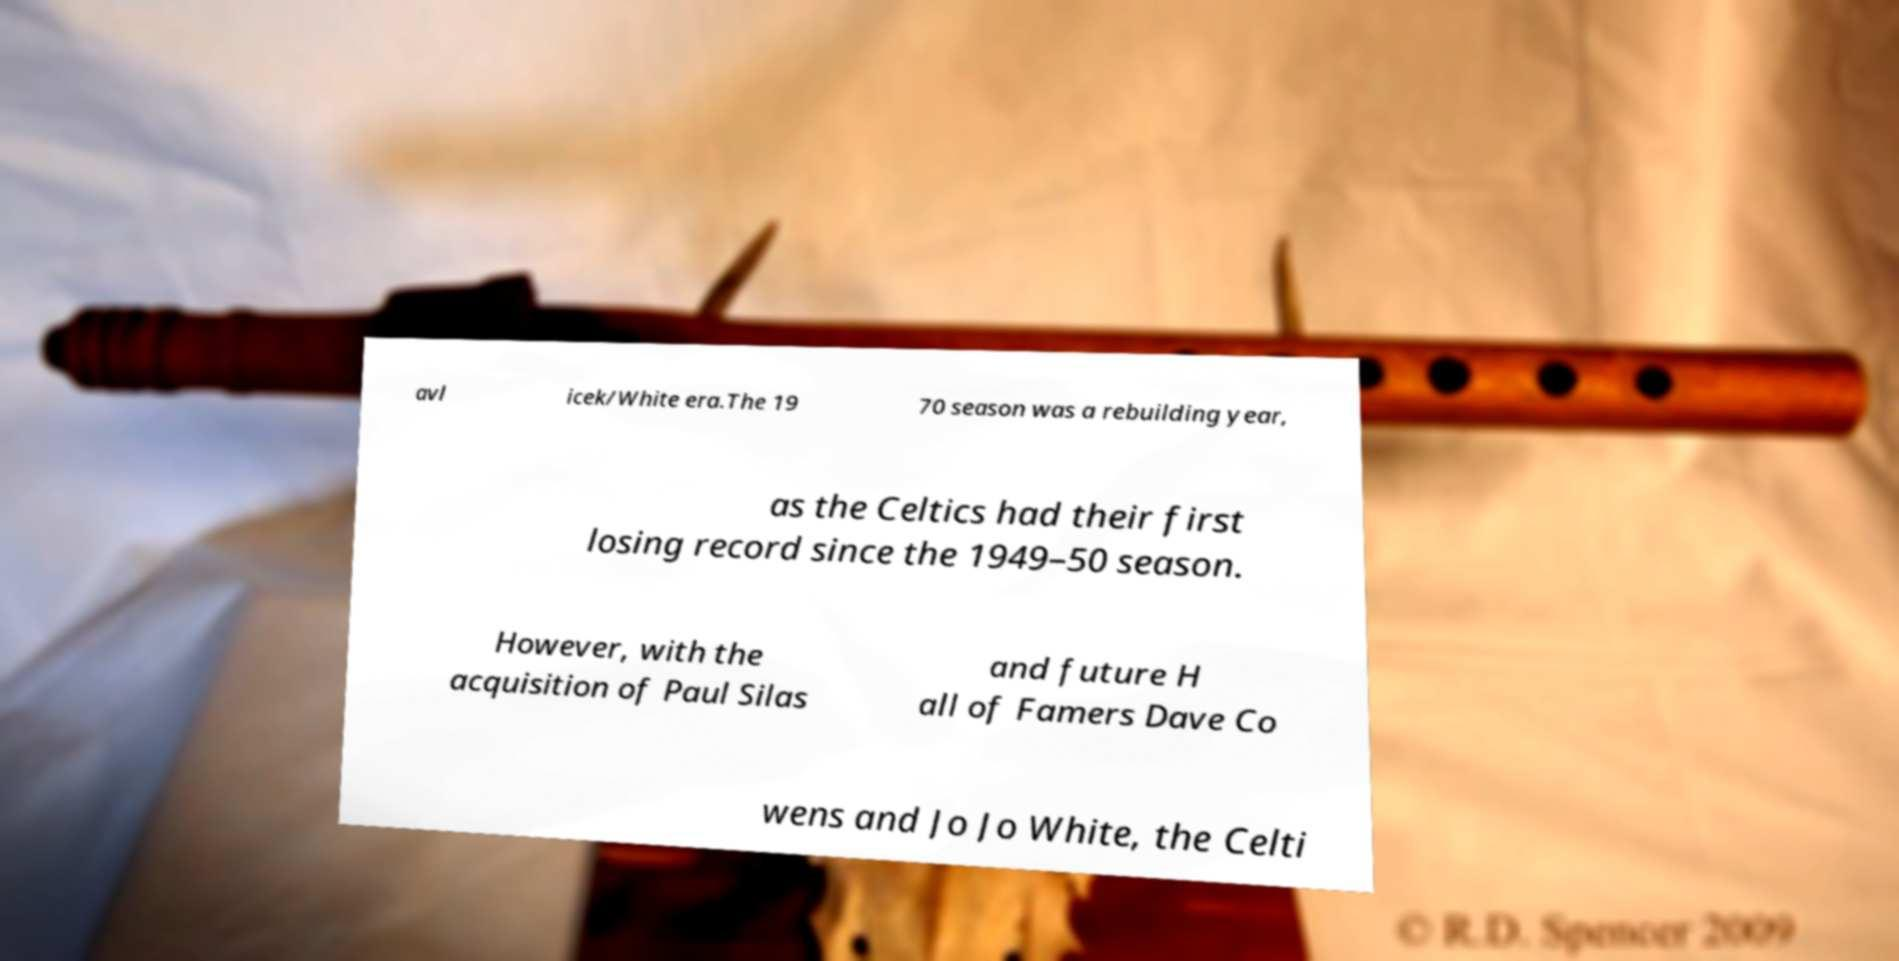Can you accurately transcribe the text from the provided image for me? avl icek/White era.The 19 70 season was a rebuilding year, as the Celtics had their first losing record since the 1949–50 season. However, with the acquisition of Paul Silas and future H all of Famers Dave Co wens and Jo Jo White, the Celti 